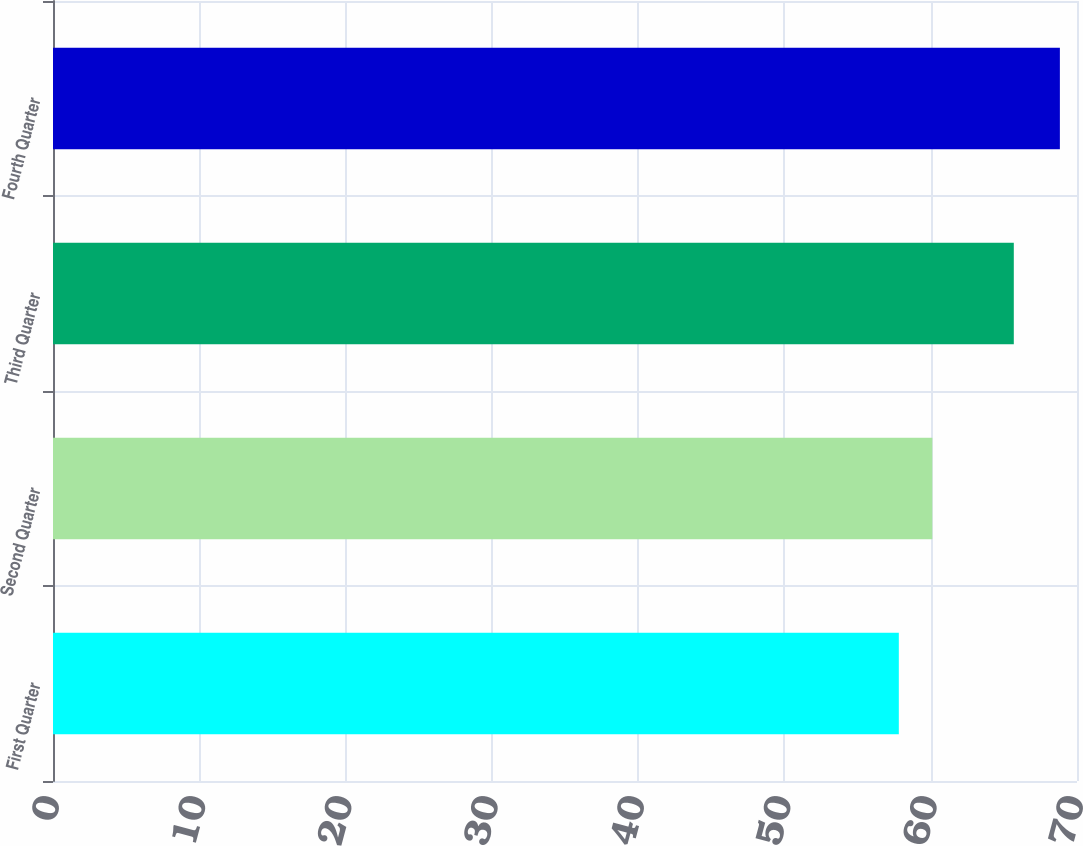Convert chart to OTSL. <chart><loc_0><loc_0><loc_500><loc_500><bar_chart><fcel>First Quarter<fcel>Second Quarter<fcel>Third Quarter<fcel>Fourth Quarter<nl><fcel>57.82<fcel>60.11<fcel>65.68<fcel>68.83<nl></chart> 